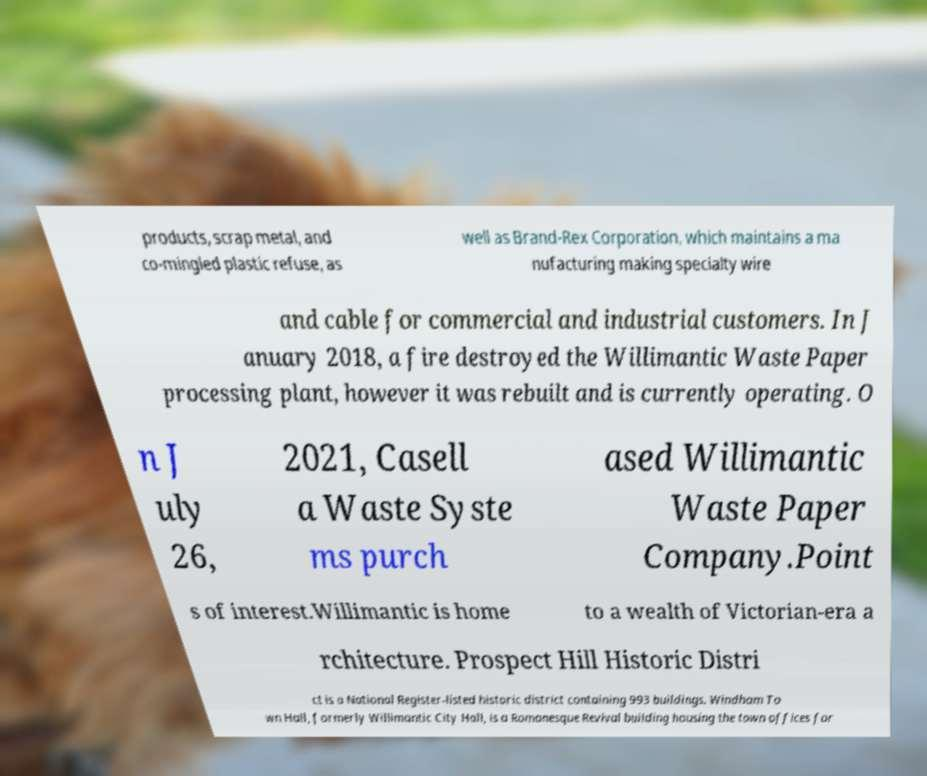Can you read and provide the text displayed in the image?This photo seems to have some interesting text. Can you extract and type it out for me? products, scrap metal, and co-mingled plastic refuse, as well as Brand-Rex Corporation, which maintains a ma nufacturing making specialty wire and cable for commercial and industrial customers. In J anuary 2018, a fire destroyed the Willimantic Waste Paper processing plant, however it was rebuilt and is currently operating. O n J uly 26, 2021, Casell a Waste Syste ms purch ased Willimantic Waste Paper Company.Point s of interest.Willimantic is home to a wealth of Victorian-era a rchitecture. Prospect Hill Historic Distri ct is a National Register-listed historic district containing 993 buildings. Windham To wn Hall, formerly Willimantic City Hall, is a Romanesque Revival building housing the town offices for 